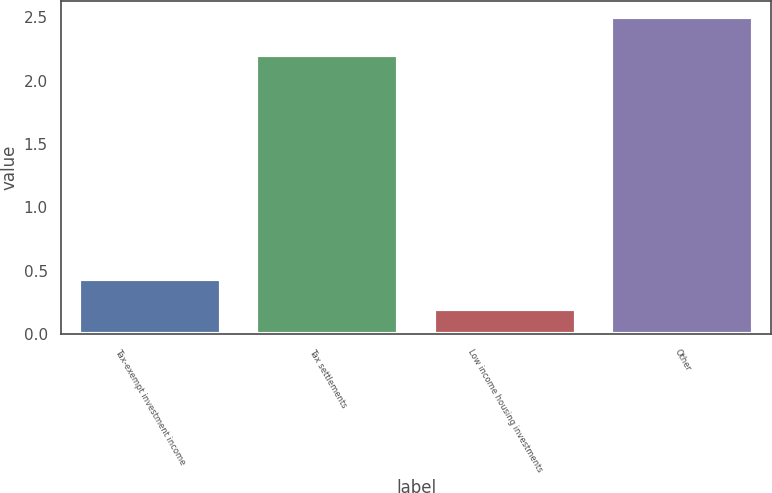<chart> <loc_0><loc_0><loc_500><loc_500><bar_chart><fcel>Tax-exempt investment income<fcel>Tax settlements<fcel>Low income housing investments<fcel>Other<nl><fcel>0.43<fcel>2.2<fcel>0.2<fcel>2.5<nl></chart> 